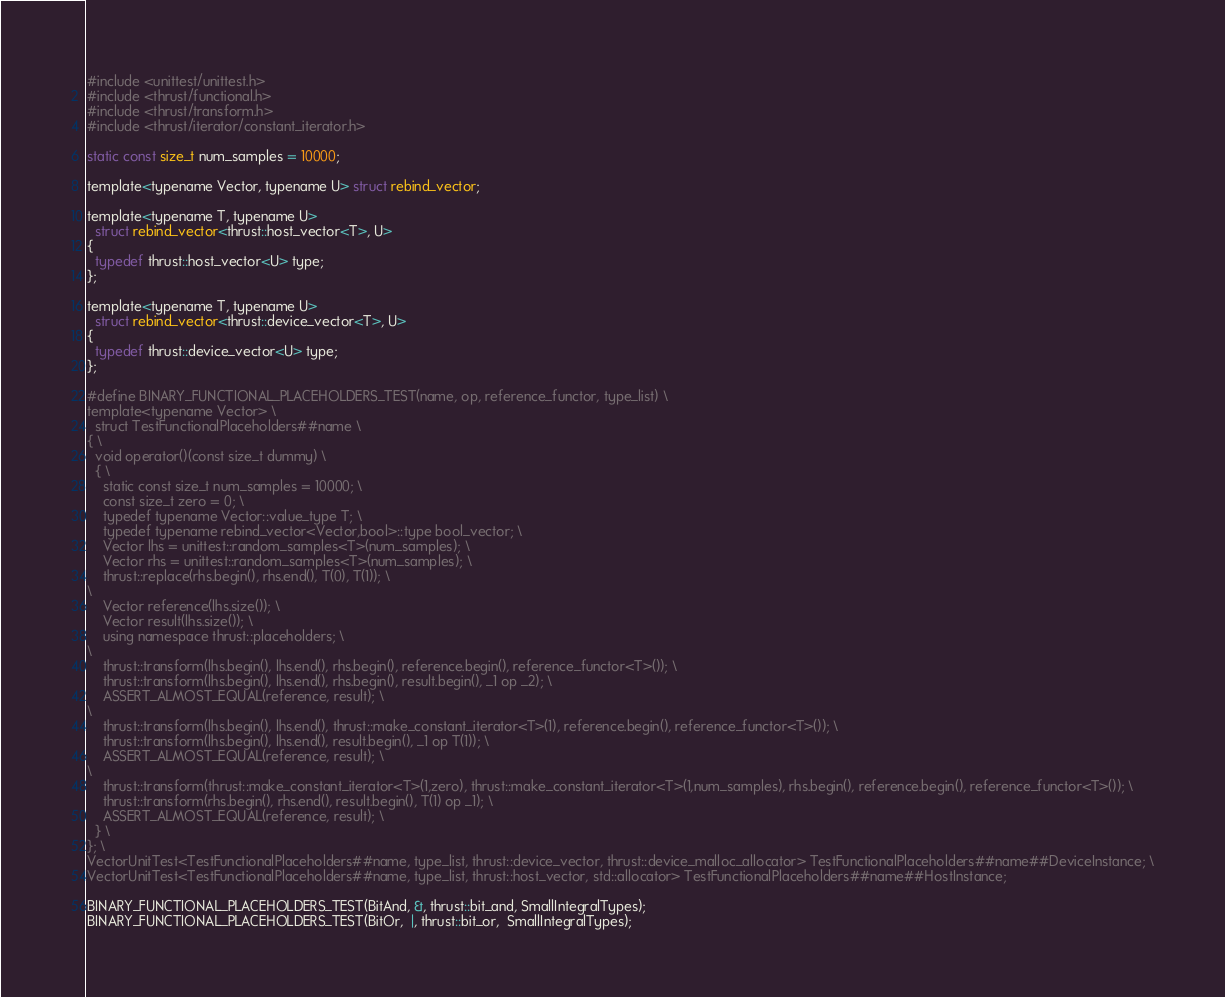<code> <loc_0><loc_0><loc_500><loc_500><_Cuda_>#include <unittest/unittest.h>
#include <thrust/functional.h>
#include <thrust/transform.h>
#include <thrust/iterator/constant_iterator.h>

static const size_t num_samples = 10000;

template<typename Vector, typename U> struct rebind_vector;

template<typename T, typename U>
  struct rebind_vector<thrust::host_vector<T>, U>
{
  typedef thrust::host_vector<U> type;
};

template<typename T, typename U>
  struct rebind_vector<thrust::device_vector<T>, U>
{
  typedef thrust::device_vector<U> type;
};

#define BINARY_FUNCTIONAL_PLACEHOLDERS_TEST(name, op, reference_functor, type_list) \
template<typename Vector> \
  struct TestFunctionalPlaceholders##name \
{ \
  void operator()(const size_t dummy) \
  { \
    static const size_t num_samples = 10000; \
    const size_t zero = 0; \
    typedef typename Vector::value_type T; \
    typedef typename rebind_vector<Vector,bool>::type bool_vector; \
    Vector lhs = unittest::random_samples<T>(num_samples); \
    Vector rhs = unittest::random_samples<T>(num_samples); \
    thrust::replace(rhs.begin(), rhs.end(), T(0), T(1)); \
\
    Vector reference(lhs.size()); \
    Vector result(lhs.size()); \
    using namespace thrust::placeholders; \
\
    thrust::transform(lhs.begin(), lhs.end(), rhs.begin(), reference.begin(), reference_functor<T>()); \
    thrust::transform(lhs.begin(), lhs.end(), rhs.begin(), result.begin(), _1 op _2); \
    ASSERT_ALMOST_EQUAL(reference, result); \
\
    thrust::transform(lhs.begin(), lhs.end(), thrust::make_constant_iterator<T>(1), reference.begin(), reference_functor<T>()); \
    thrust::transform(lhs.begin(), lhs.end(), result.begin(), _1 op T(1)); \
    ASSERT_ALMOST_EQUAL(reference, result); \
\
    thrust::transform(thrust::make_constant_iterator<T>(1,zero), thrust::make_constant_iterator<T>(1,num_samples), rhs.begin(), reference.begin(), reference_functor<T>()); \
    thrust::transform(rhs.begin(), rhs.end(), result.begin(), T(1) op _1); \
    ASSERT_ALMOST_EQUAL(reference, result); \
  } \
}; \
VectorUnitTest<TestFunctionalPlaceholders##name, type_list, thrust::device_vector, thrust::device_malloc_allocator> TestFunctionalPlaceholders##name##DeviceInstance; \
VectorUnitTest<TestFunctionalPlaceholders##name, type_list, thrust::host_vector, std::allocator> TestFunctionalPlaceholders##name##HostInstance;

BINARY_FUNCTIONAL_PLACEHOLDERS_TEST(BitAnd, &, thrust::bit_and, SmallIntegralTypes);
BINARY_FUNCTIONAL_PLACEHOLDERS_TEST(BitOr,  |, thrust::bit_or,  SmallIntegralTypes);</code> 